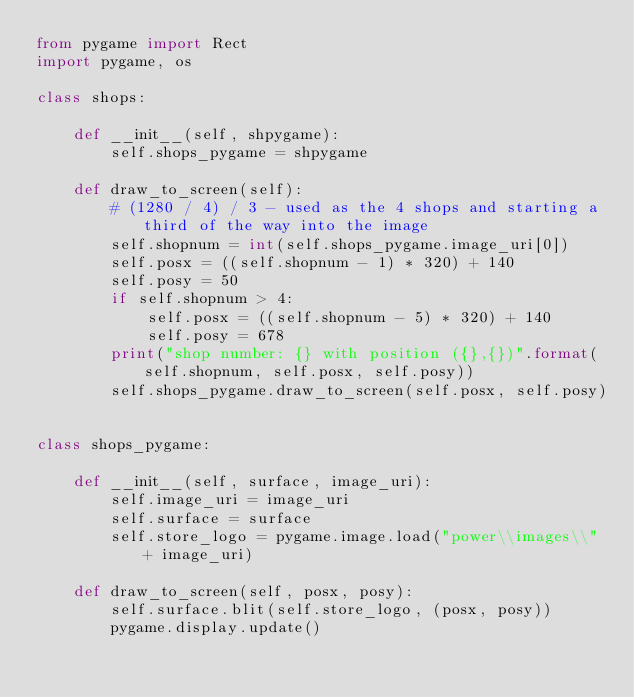Convert code to text. <code><loc_0><loc_0><loc_500><loc_500><_Python_>from pygame import Rect
import pygame, os

class shops:

    def __init__(self, shpygame):
        self.shops_pygame = shpygame

    def draw_to_screen(self):
        # (1280 / 4) / 3 - used as the 4 shops and starting a third of the way into the image
        self.shopnum = int(self.shops_pygame.image_uri[0])
        self.posx = ((self.shopnum - 1) * 320) + 140
        self.posy = 50
        if self.shopnum > 4: 
            self.posx = ((self.shopnum - 5) * 320) + 140
            self.posy = 678
        print("shop number: {} with position ({},{})".format(self.shopnum, self.posx, self.posy))
        self.shops_pygame.draw_to_screen(self.posx, self.posy)
        

class shops_pygame:

    def __init__(self, surface, image_uri):
        self.image_uri = image_uri
        self.surface = surface
        self.store_logo = pygame.image.load("power\\images\\" + image_uri)

    def draw_to_screen(self, posx, posy):
        self.surface.blit(self.store_logo, (posx, posy))
        pygame.display.update()</code> 